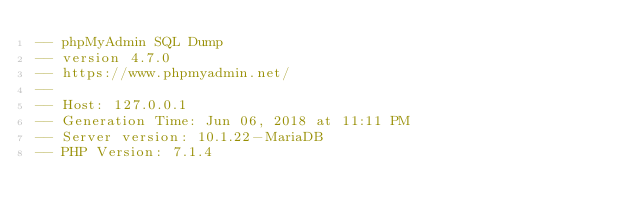<code> <loc_0><loc_0><loc_500><loc_500><_SQL_>-- phpMyAdmin SQL Dump
-- version 4.7.0
-- https://www.phpmyadmin.net/
--
-- Host: 127.0.0.1
-- Generation Time: Jun 06, 2018 at 11:11 PM
-- Server version: 10.1.22-MariaDB
-- PHP Version: 7.1.4
</code> 